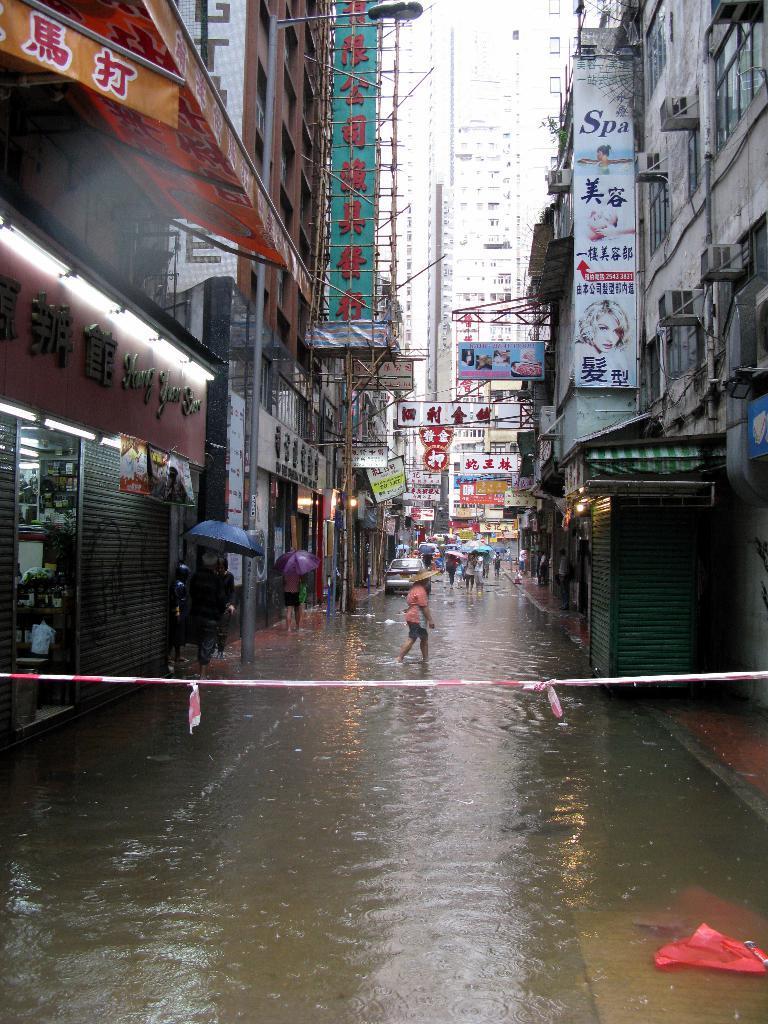In one or two sentences, can you explain what this image depicts? In this image I can see some people and vehicles. I can see the water. On the left and right side, I can see the buildings. 